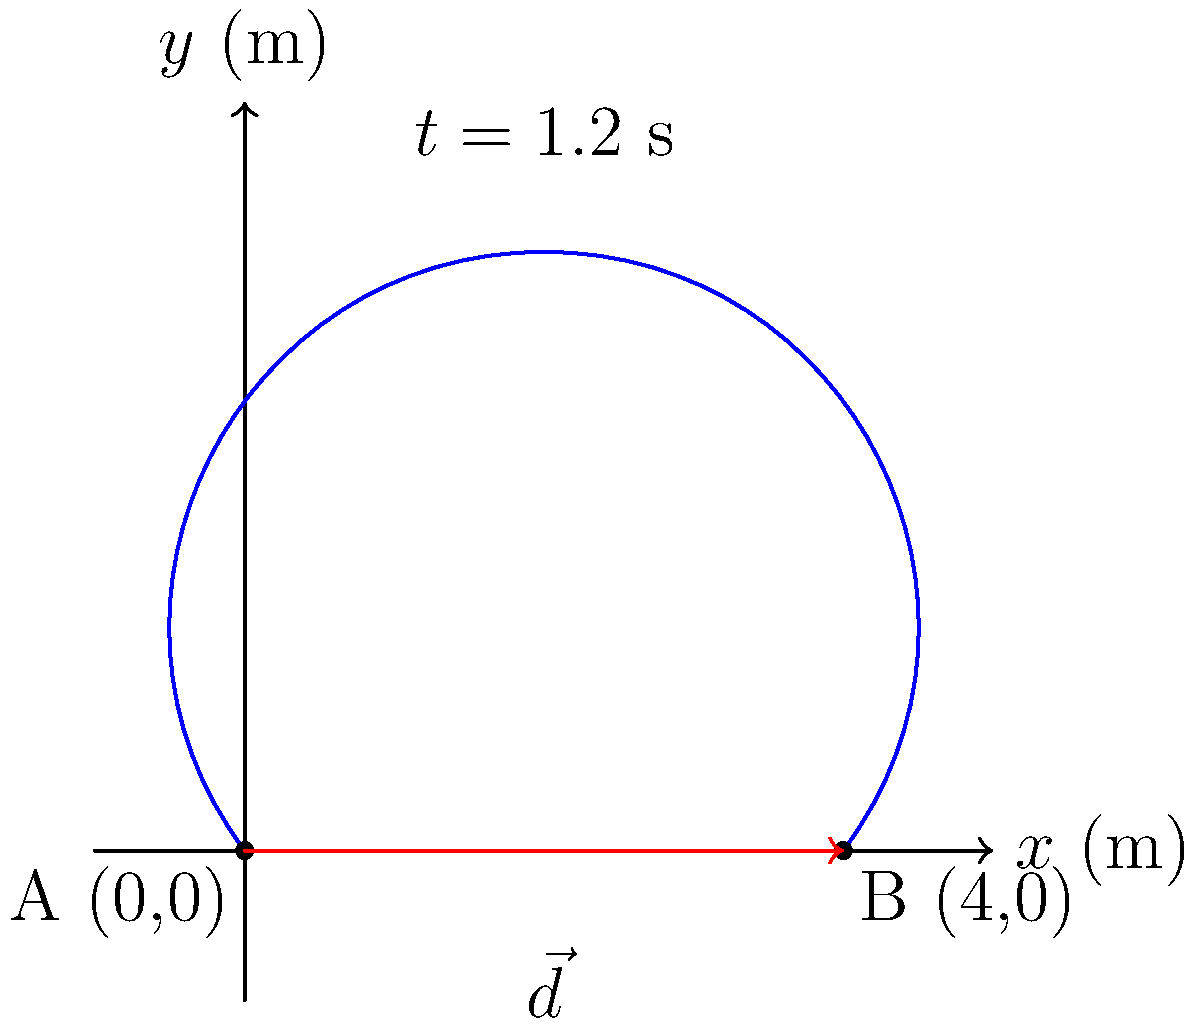During a Letran Knights basketball game, a player takes a jump shot. The ball leaves the player's hand at point A (0,0) and lands in the basket at point B (4,0) after 1.2 seconds, following the parabolic path shown in the diagram. Calculate the velocity vector of the ball. To find the velocity vector, we need to follow these steps:

1) First, identify the displacement vector $\vec{d}$:
   $\vec{d} = \vec{B} - \vec{A} = (4,0) - (0,0) = (4,0)$ meters

2) The time taken for the ball to travel from A to B is given as 1.2 seconds.

3) Recall that average velocity $\vec{v}$ is given by:
   $$\vec{v} = \frac{\Delta \vec{r}}{\Delta t} = \frac{\vec{d}}{t}$$

4) Substitute the values:
   $$\vec{v} = \frac{(4,0)}{1.2}$$

5) Perform the division:
   $$\vec{v} = (\frac{4}{1.2}, \frac{0}{1.2}) = (3.33, 0)$$

Therefore, the velocity vector of the ball is (3.33, 0) meters per second.
Answer: $(3.33, 0)$ m/s 